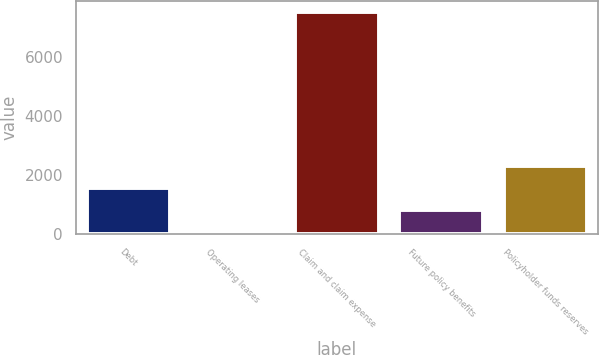Convert chart to OTSL. <chart><loc_0><loc_0><loc_500><loc_500><bar_chart><fcel>Debt<fcel>Operating leases<fcel>Claim and claim expense<fcel>Future policy benefits<fcel>Policyholder funds reserves<nl><fcel>1561.92<fcel>71.9<fcel>7522<fcel>816.91<fcel>2306.93<nl></chart> 